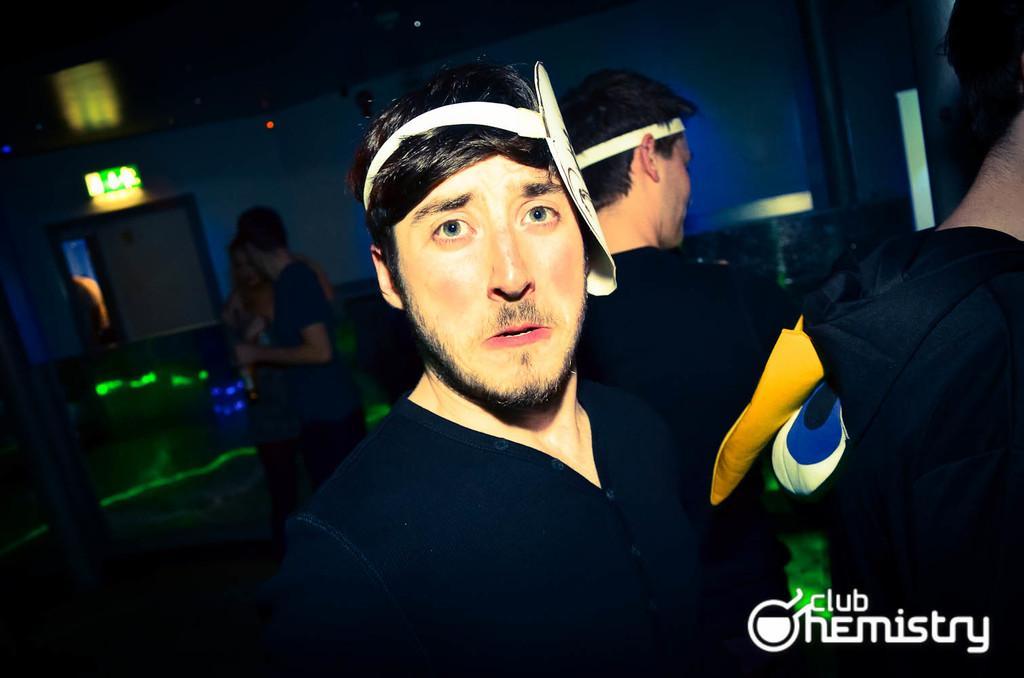How would you summarize this image in a sentence or two? As we can see in the image there are few people here and there, lights and wall. The image is little dark. The people in the front are wearing black color dresses. 